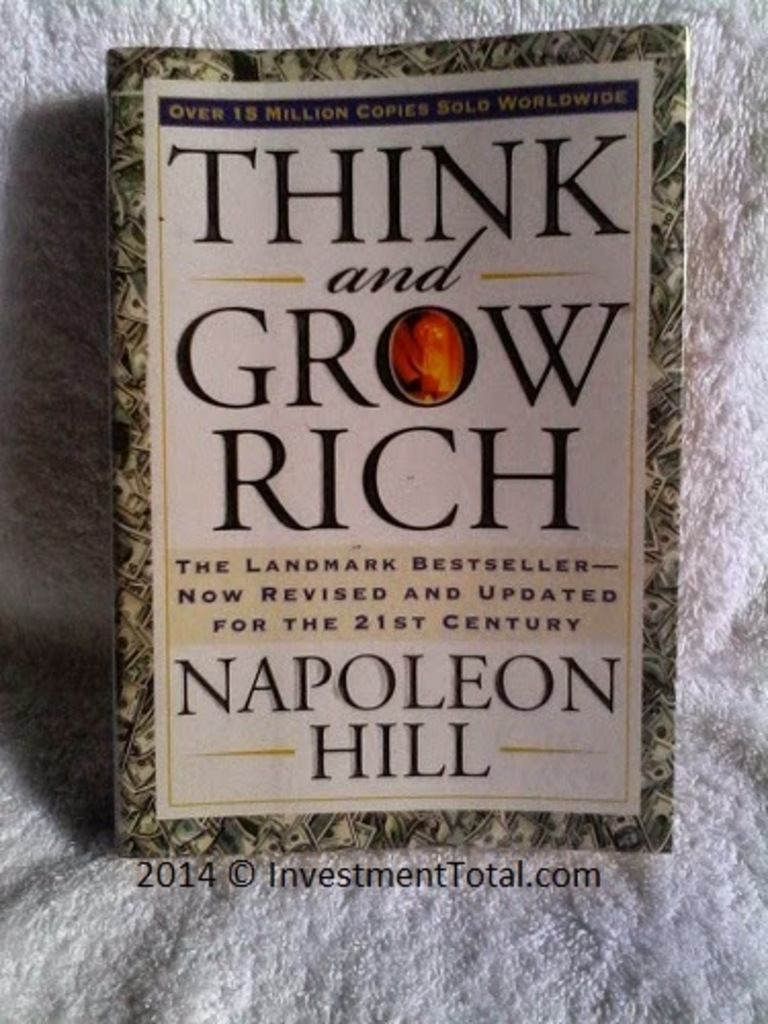How has 'Think and Grow Rich' impacted readers globally? The book has had a colossal impact, selling over 15 million copies globally and influencing countless readers. Its principles of vision, determination, and mental fortitude have been applied across diverse fields, motivating individuals to harness their personal power and pursue ambitious goals. The enduring popularity of 'Think and Grow Rich' speaks to its effectiveness in inspiring readers to cultivate a rich mindset that transcends monetary wealth, emphasizing personal development and self-discipline. 